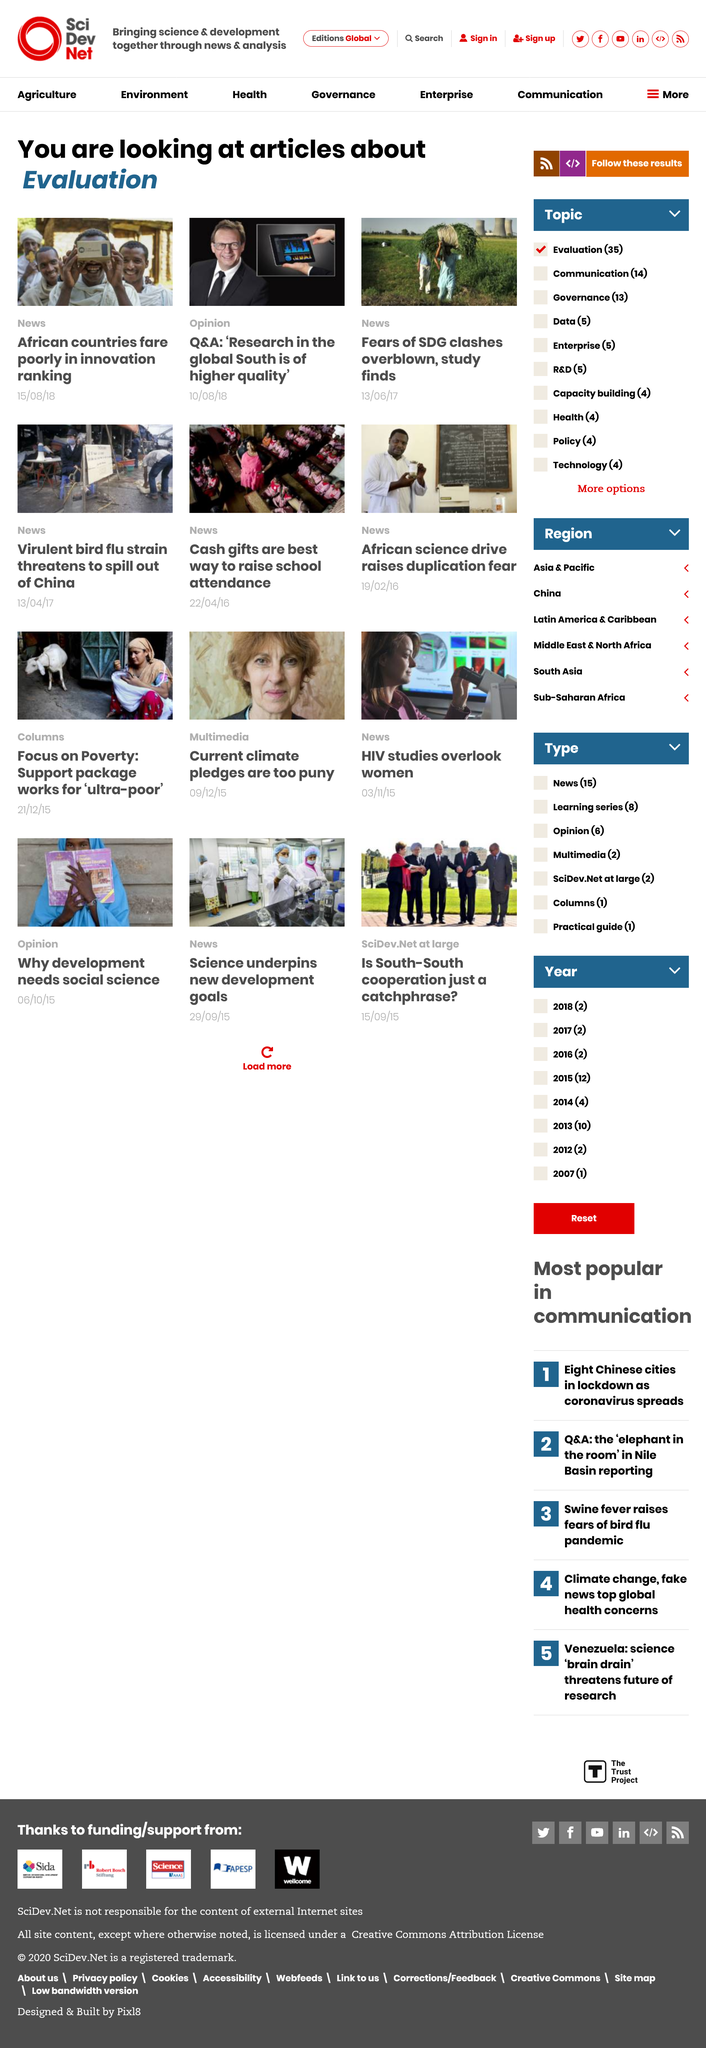Give some essential details in this illustration. A recent study has revealed that fears of SDG clashes are largely exaggerated, suggesting that SDG clashes are not as prevalent as previously thought. In the article published in the News category, African countries are shown to perform poorly in the innovation ranking. I am able to accurately determine that one of the articles is an opinion piece and two are news articles. 